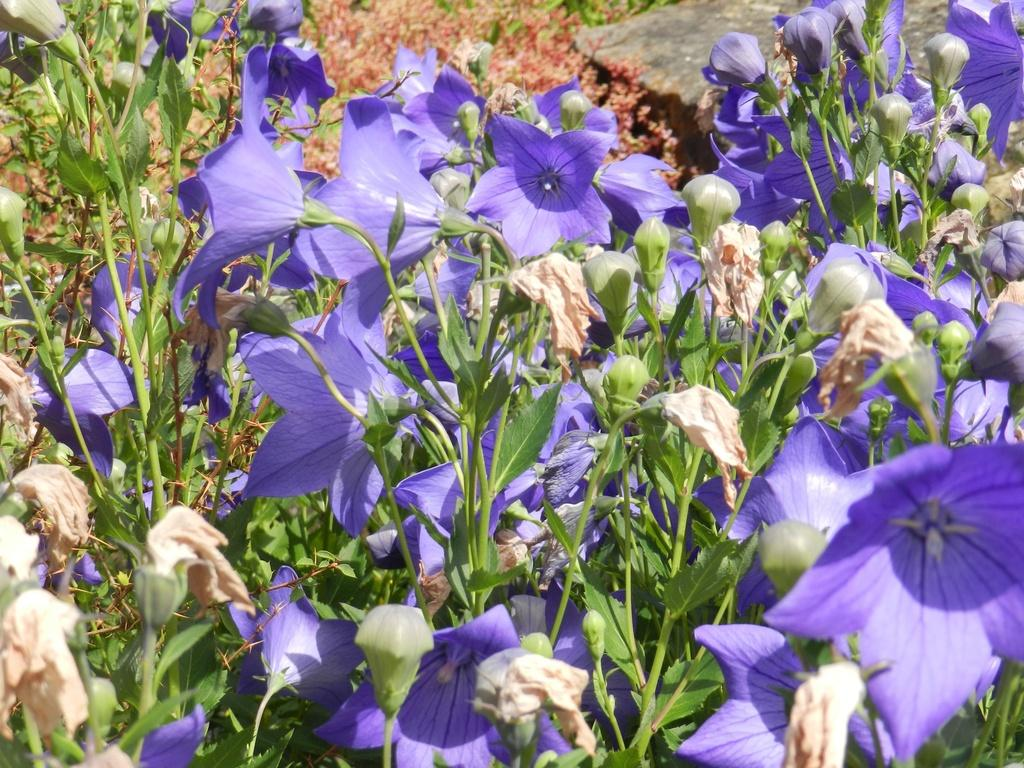What is the main subject of the image? The main subject of the image is many plants. What can be observed about the plants in the image? The plants have beautiful flowers. Are there any signs of future blooms on the plants? Yes, there are flower buds present on the plants. What type of request can be seen written on the farm in the image? There is no farm or request present in the image; it features many plants with beautiful flowers and flower buds. 